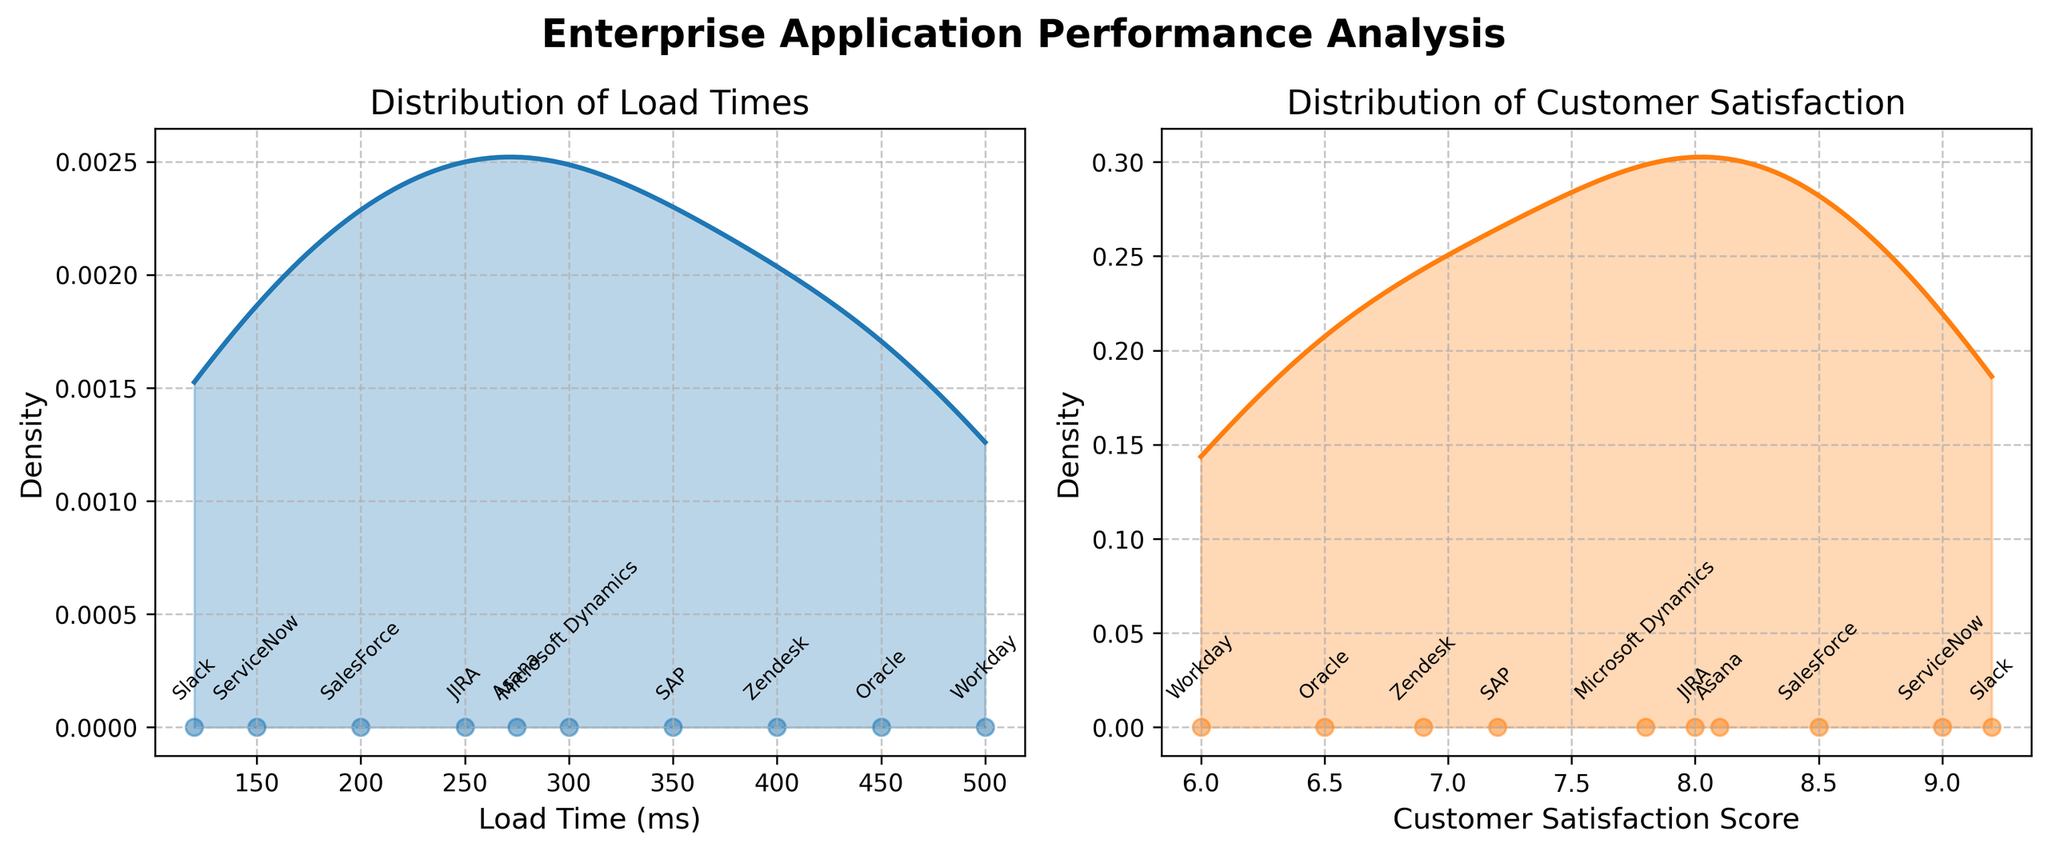What is the title of the figure? The title of the figure is clearly shown at the top of the plot in bold font. It reads "Enterprise Application Performance Analysis".
Answer: Enterprise Application Performance Analysis How many enterprise applications are included in the plot? Each scatter point and annotation on the subplots represent an enterprise application. By counting them, there are 10 applications present.
Answer: 10 Which application has the highest customer satisfaction score? We look at the scatter plot overlay on the customer satisfaction density plot. The highest annotated point corresponds to Slack with a score of 9.2.
Answer: Slack Which application has the longest load time? Observing the scatter plot on the load time density plot, the farthest point on the x-axis corresponds to Workday with a load time of 500 ms.
Answer: Workday Describe the overall distribution of load times. The density plot for load times shows a smoother curve mostly centered around mid-values with clear peaks. This indicates that load times are spread out across low to high values with some common middle-range values.
Answer: Spread out with a peak around middle values Are there more applications with customer satisfaction scores above 8 or below 8? To answer this, review the scatter points on the customer satisfaction density plot. Count the number of points above and below the score of 8. There are 5 scores above 8 (SalesForce, ServiceNow, Slack, JIRA, Asana) and 5 below 8.
Answer: Equal number Is there any application with a satisfaction score but no corresponding load time shown? By checking both subplots, each scatter point on the load time density plot has a corresponding point on the customer satisfaction density plot, indicating that all applications have both metrics displayed.
Answer: No Which application has the shortest load time? Comparing the scatter points on the load time density plot, the nearest point to the origin (smallest x-value) corresponds to Slack with a load time of 120 ms.
Answer: Slack Does higher customer satisfaction generally correlate with lower load times? By observing the scatter points from both subplots, we see that applications with high satisfaction scores (e.g., Slack, ServiceNow) tend to have lower load times, suggesting a negative correlation.
Answer: Yes, generally Identify the range of load times represented in the plot. The x-axis on the load time density plot starts from around 100 ms to 500 ms, indicating that load times spread within this range.
Answer: 100 ms to 500 ms 